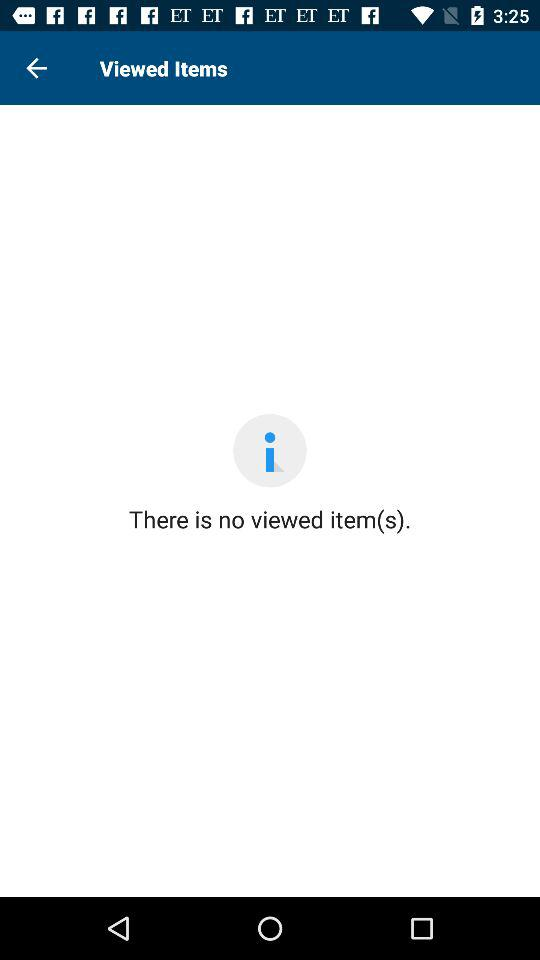How many viewed items are there?
Answer the question using a single word or phrase. 0 